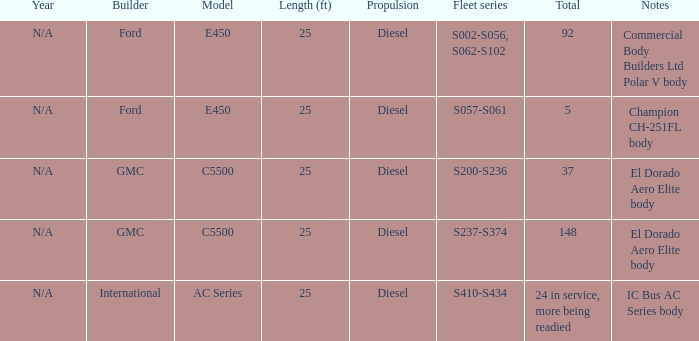What are the notes for Ford when the total is 5? Champion CH-251FL body. 